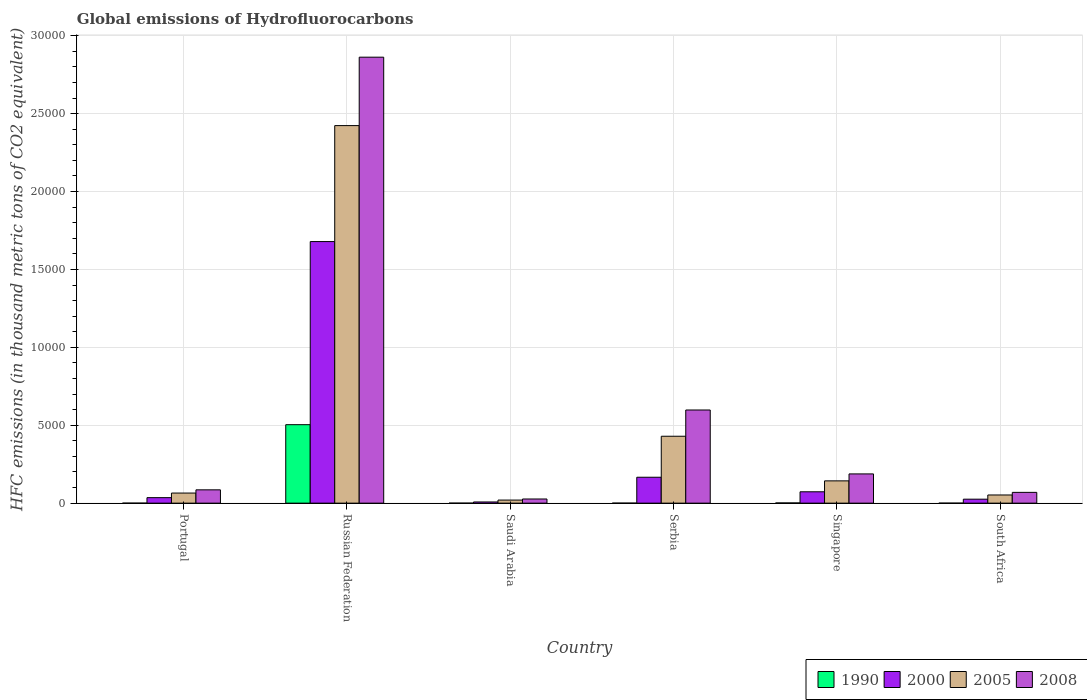How many different coloured bars are there?
Keep it short and to the point. 4. How many groups of bars are there?
Offer a very short reply. 6. Are the number of bars on each tick of the X-axis equal?
Make the answer very short. Yes. What is the label of the 5th group of bars from the left?
Provide a short and direct response. Singapore. What is the global emissions of Hydrofluorocarbons in 2005 in Saudi Arabia?
Provide a succinct answer. 196.9. Across all countries, what is the maximum global emissions of Hydrofluorocarbons in 2008?
Keep it short and to the point. 2.86e+04. In which country was the global emissions of Hydrofluorocarbons in 2000 maximum?
Your response must be concise. Russian Federation. In which country was the global emissions of Hydrofluorocarbons in 2000 minimum?
Make the answer very short. Saudi Arabia. What is the total global emissions of Hydrofluorocarbons in 2008 in the graph?
Keep it short and to the point. 3.83e+04. What is the difference between the global emissions of Hydrofluorocarbons in 1990 in Serbia and that in Singapore?
Offer a terse response. -12.1. What is the difference between the global emissions of Hydrofluorocarbons in 2005 in South Africa and the global emissions of Hydrofluorocarbons in 2000 in Russian Federation?
Your response must be concise. -1.63e+04. What is the average global emissions of Hydrofluorocarbons in 2005 per country?
Provide a succinct answer. 5220.65. What is the difference between the global emissions of Hydrofluorocarbons of/in 2005 and global emissions of Hydrofluorocarbons of/in 2000 in Serbia?
Provide a short and direct response. 2631.8. In how many countries, is the global emissions of Hydrofluorocarbons in 1990 greater than 4000 thousand metric tons?
Give a very brief answer. 1. What is the ratio of the global emissions of Hydrofluorocarbons in 2008 in Portugal to that in Saudi Arabia?
Offer a terse response. 3.21. What is the difference between the highest and the second highest global emissions of Hydrofluorocarbons in 1990?
Provide a succinct answer. -5035.1. What is the difference between the highest and the lowest global emissions of Hydrofluorocarbons in 2008?
Offer a terse response. 2.84e+04. In how many countries, is the global emissions of Hydrofluorocarbons in 1990 greater than the average global emissions of Hydrofluorocarbons in 1990 taken over all countries?
Your answer should be very brief. 1. Is the sum of the global emissions of Hydrofluorocarbons in 2008 in Serbia and Singapore greater than the maximum global emissions of Hydrofluorocarbons in 2000 across all countries?
Your answer should be compact. No. What does the 4th bar from the left in Russian Federation represents?
Offer a very short reply. 2008. What does the 4th bar from the right in Serbia represents?
Your response must be concise. 1990. Is it the case that in every country, the sum of the global emissions of Hydrofluorocarbons in 1990 and global emissions of Hydrofluorocarbons in 2008 is greater than the global emissions of Hydrofluorocarbons in 2005?
Your answer should be compact. Yes. How many countries are there in the graph?
Keep it short and to the point. 6. What is the difference between two consecutive major ticks on the Y-axis?
Your answer should be compact. 5000. Are the values on the major ticks of Y-axis written in scientific E-notation?
Your answer should be compact. No. Does the graph contain any zero values?
Your answer should be very brief. No. Where does the legend appear in the graph?
Provide a short and direct response. Bottom right. How many legend labels are there?
Offer a very short reply. 4. How are the legend labels stacked?
Keep it short and to the point. Horizontal. What is the title of the graph?
Your answer should be very brief. Global emissions of Hydrofluorocarbons. What is the label or title of the X-axis?
Provide a short and direct response. Country. What is the label or title of the Y-axis?
Your answer should be compact. HFC emissions (in thousand metric tons of CO2 equivalent). What is the HFC emissions (in thousand metric tons of CO2 equivalent) of 2000 in Portugal?
Provide a succinct answer. 352.7. What is the HFC emissions (in thousand metric tons of CO2 equivalent) of 2005 in Portugal?
Provide a short and direct response. 647.7. What is the HFC emissions (in thousand metric tons of CO2 equivalent) of 2008 in Portugal?
Your response must be concise. 854.4. What is the HFC emissions (in thousand metric tons of CO2 equivalent) of 1990 in Russian Federation?
Your response must be concise. 5035.6. What is the HFC emissions (in thousand metric tons of CO2 equivalent) in 2000 in Russian Federation?
Give a very brief answer. 1.68e+04. What is the HFC emissions (in thousand metric tons of CO2 equivalent) in 2005 in Russian Federation?
Your response must be concise. 2.42e+04. What is the HFC emissions (in thousand metric tons of CO2 equivalent) in 2008 in Russian Federation?
Your response must be concise. 2.86e+04. What is the HFC emissions (in thousand metric tons of CO2 equivalent) of 1990 in Saudi Arabia?
Offer a terse response. 0.1. What is the HFC emissions (in thousand metric tons of CO2 equivalent) of 2000 in Saudi Arabia?
Your answer should be very brief. 75.5. What is the HFC emissions (in thousand metric tons of CO2 equivalent) of 2005 in Saudi Arabia?
Your response must be concise. 196.9. What is the HFC emissions (in thousand metric tons of CO2 equivalent) in 2008 in Saudi Arabia?
Keep it short and to the point. 266.5. What is the HFC emissions (in thousand metric tons of CO2 equivalent) of 1990 in Serbia?
Offer a very short reply. 0.5. What is the HFC emissions (in thousand metric tons of CO2 equivalent) of 2000 in Serbia?
Keep it short and to the point. 1662. What is the HFC emissions (in thousand metric tons of CO2 equivalent) in 2005 in Serbia?
Ensure brevity in your answer.  4293.8. What is the HFC emissions (in thousand metric tons of CO2 equivalent) in 2008 in Serbia?
Offer a terse response. 5979. What is the HFC emissions (in thousand metric tons of CO2 equivalent) of 1990 in Singapore?
Keep it short and to the point. 12.6. What is the HFC emissions (in thousand metric tons of CO2 equivalent) in 2000 in Singapore?
Offer a very short reply. 728.9. What is the HFC emissions (in thousand metric tons of CO2 equivalent) in 2005 in Singapore?
Keep it short and to the point. 1429.7. What is the HFC emissions (in thousand metric tons of CO2 equivalent) of 2008 in Singapore?
Offer a very short reply. 1876.4. What is the HFC emissions (in thousand metric tons of CO2 equivalent) of 1990 in South Africa?
Give a very brief answer. 0.2. What is the HFC emissions (in thousand metric tons of CO2 equivalent) in 2000 in South Africa?
Your answer should be compact. 254.6. What is the HFC emissions (in thousand metric tons of CO2 equivalent) of 2005 in South Africa?
Ensure brevity in your answer.  524.5. What is the HFC emissions (in thousand metric tons of CO2 equivalent) in 2008 in South Africa?
Provide a short and direct response. 691.6. Across all countries, what is the maximum HFC emissions (in thousand metric tons of CO2 equivalent) of 1990?
Give a very brief answer. 5035.6. Across all countries, what is the maximum HFC emissions (in thousand metric tons of CO2 equivalent) of 2000?
Make the answer very short. 1.68e+04. Across all countries, what is the maximum HFC emissions (in thousand metric tons of CO2 equivalent) of 2005?
Your answer should be very brief. 2.42e+04. Across all countries, what is the maximum HFC emissions (in thousand metric tons of CO2 equivalent) of 2008?
Ensure brevity in your answer.  2.86e+04. Across all countries, what is the minimum HFC emissions (in thousand metric tons of CO2 equivalent) of 2000?
Offer a very short reply. 75.5. Across all countries, what is the minimum HFC emissions (in thousand metric tons of CO2 equivalent) in 2005?
Your answer should be compact. 196.9. Across all countries, what is the minimum HFC emissions (in thousand metric tons of CO2 equivalent) of 2008?
Your answer should be very brief. 266.5. What is the total HFC emissions (in thousand metric tons of CO2 equivalent) of 1990 in the graph?
Offer a terse response. 5049.2. What is the total HFC emissions (in thousand metric tons of CO2 equivalent) in 2000 in the graph?
Your answer should be very brief. 1.99e+04. What is the total HFC emissions (in thousand metric tons of CO2 equivalent) in 2005 in the graph?
Keep it short and to the point. 3.13e+04. What is the total HFC emissions (in thousand metric tons of CO2 equivalent) in 2008 in the graph?
Offer a very short reply. 3.83e+04. What is the difference between the HFC emissions (in thousand metric tons of CO2 equivalent) in 1990 in Portugal and that in Russian Federation?
Ensure brevity in your answer.  -5035.4. What is the difference between the HFC emissions (in thousand metric tons of CO2 equivalent) of 2000 in Portugal and that in Russian Federation?
Offer a very short reply. -1.64e+04. What is the difference between the HFC emissions (in thousand metric tons of CO2 equivalent) in 2005 in Portugal and that in Russian Federation?
Your response must be concise. -2.36e+04. What is the difference between the HFC emissions (in thousand metric tons of CO2 equivalent) in 2008 in Portugal and that in Russian Federation?
Ensure brevity in your answer.  -2.78e+04. What is the difference between the HFC emissions (in thousand metric tons of CO2 equivalent) in 1990 in Portugal and that in Saudi Arabia?
Keep it short and to the point. 0.1. What is the difference between the HFC emissions (in thousand metric tons of CO2 equivalent) in 2000 in Portugal and that in Saudi Arabia?
Provide a short and direct response. 277.2. What is the difference between the HFC emissions (in thousand metric tons of CO2 equivalent) of 2005 in Portugal and that in Saudi Arabia?
Provide a short and direct response. 450.8. What is the difference between the HFC emissions (in thousand metric tons of CO2 equivalent) in 2008 in Portugal and that in Saudi Arabia?
Your answer should be very brief. 587.9. What is the difference between the HFC emissions (in thousand metric tons of CO2 equivalent) of 2000 in Portugal and that in Serbia?
Provide a short and direct response. -1309.3. What is the difference between the HFC emissions (in thousand metric tons of CO2 equivalent) of 2005 in Portugal and that in Serbia?
Your answer should be compact. -3646.1. What is the difference between the HFC emissions (in thousand metric tons of CO2 equivalent) of 2008 in Portugal and that in Serbia?
Provide a succinct answer. -5124.6. What is the difference between the HFC emissions (in thousand metric tons of CO2 equivalent) in 1990 in Portugal and that in Singapore?
Make the answer very short. -12.4. What is the difference between the HFC emissions (in thousand metric tons of CO2 equivalent) of 2000 in Portugal and that in Singapore?
Make the answer very short. -376.2. What is the difference between the HFC emissions (in thousand metric tons of CO2 equivalent) in 2005 in Portugal and that in Singapore?
Your answer should be very brief. -782. What is the difference between the HFC emissions (in thousand metric tons of CO2 equivalent) in 2008 in Portugal and that in Singapore?
Keep it short and to the point. -1022. What is the difference between the HFC emissions (in thousand metric tons of CO2 equivalent) of 2000 in Portugal and that in South Africa?
Your answer should be very brief. 98.1. What is the difference between the HFC emissions (in thousand metric tons of CO2 equivalent) of 2005 in Portugal and that in South Africa?
Offer a terse response. 123.2. What is the difference between the HFC emissions (in thousand metric tons of CO2 equivalent) of 2008 in Portugal and that in South Africa?
Make the answer very short. 162.8. What is the difference between the HFC emissions (in thousand metric tons of CO2 equivalent) in 1990 in Russian Federation and that in Saudi Arabia?
Provide a short and direct response. 5035.5. What is the difference between the HFC emissions (in thousand metric tons of CO2 equivalent) of 2000 in Russian Federation and that in Saudi Arabia?
Your answer should be compact. 1.67e+04. What is the difference between the HFC emissions (in thousand metric tons of CO2 equivalent) of 2005 in Russian Federation and that in Saudi Arabia?
Provide a short and direct response. 2.40e+04. What is the difference between the HFC emissions (in thousand metric tons of CO2 equivalent) of 2008 in Russian Federation and that in Saudi Arabia?
Make the answer very short. 2.84e+04. What is the difference between the HFC emissions (in thousand metric tons of CO2 equivalent) of 1990 in Russian Federation and that in Serbia?
Keep it short and to the point. 5035.1. What is the difference between the HFC emissions (in thousand metric tons of CO2 equivalent) of 2000 in Russian Federation and that in Serbia?
Provide a succinct answer. 1.51e+04. What is the difference between the HFC emissions (in thousand metric tons of CO2 equivalent) of 2005 in Russian Federation and that in Serbia?
Your answer should be compact. 1.99e+04. What is the difference between the HFC emissions (in thousand metric tons of CO2 equivalent) of 2008 in Russian Federation and that in Serbia?
Give a very brief answer. 2.26e+04. What is the difference between the HFC emissions (in thousand metric tons of CO2 equivalent) in 1990 in Russian Federation and that in Singapore?
Your answer should be compact. 5023. What is the difference between the HFC emissions (in thousand metric tons of CO2 equivalent) in 2000 in Russian Federation and that in Singapore?
Keep it short and to the point. 1.61e+04. What is the difference between the HFC emissions (in thousand metric tons of CO2 equivalent) in 2005 in Russian Federation and that in Singapore?
Keep it short and to the point. 2.28e+04. What is the difference between the HFC emissions (in thousand metric tons of CO2 equivalent) in 2008 in Russian Federation and that in Singapore?
Keep it short and to the point. 2.67e+04. What is the difference between the HFC emissions (in thousand metric tons of CO2 equivalent) in 1990 in Russian Federation and that in South Africa?
Provide a succinct answer. 5035.4. What is the difference between the HFC emissions (in thousand metric tons of CO2 equivalent) in 2000 in Russian Federation and that in South Africa?
Give a very brief answer. 1.65e+04. What is the difference between the HFC emissions (in thousand metric tons of CO2 equivalent) in 2005 in Russian Federation and that in South Africa?
Provide a short and direct response. 2.37e+04. What is the difference between the HFC emissions (in thousand metric tons of CO2 equivalent) of 2008 in Russian Federation and that in South Africa?
Your response must be concise. 2.79e+04. What is the difference between the HFC emissions (in thousand metric tons of CO2 equivalent) in 1990 in Saudi Arabia and that in Serbia?
Provide a succinct answer. -0.4. What is the difference between the HFC emissions (in thousand metric tons of CO2 equivalent) in 2000 in Saudi Arabia and that in Serbia?
Ensure brevity in your answer.  -1586.5. What is the difference between the HFC emissions (in thousand metric tons of CO2 equivalent) in 2005 in Saudi Arabia and that in Serbia?
Your answer should be compact. -4096.9. What is the difference between the HFC emissions (in thousand metric tons of CO2 equivalent) in 2008 in Saudi Arabia and that in Serbia?
Make the answer very short. -5712.5. What is the difference between the HFC emissions (in thousand metric tons of CO2 equivalent) of 2000 in Saudi Arabia and that in Singapore?
Provide a short and direct response. -653.4. What is the difference between the HFC emissions (in thousand metric tons of CO2 equivalent) of 2005 in Saudi Arabia and that in Singapore?
Ensure brevity in your answer.  -1232.8. What is the difference between the HFC emissions (in thousand metric tons of CO2 equivalent) of 2008 in Saudi Arabia and that in Singapore?
Your response must be concise. -1609.9. What is the difference between the HFC emissions (in thousand metric tons of CO2 equivalent) in 2000 in Saudi Arabia and that in South Africa?
Keep it short and to the point. -179.1. What is the difference between the HFC emissions (in thousand metric tons of CO2 equivalent) in 2005 in Saudi Arabia and that in South Africa?
Your answer should be compact. -327.6. What is the difference between the HFC emissions (in thousand metric tons of CO2 equivalent) in 2008 in Saudi Arabia and that in South Africa?
Offer a very short reply. -425.1. What is the difference between the HFC emissions (in thousand metric tons of CO2 equivalent) in 2000 in Serbia and that in Singapore?
Make the answer very short. 933.1. What is the difference between the HFC emissions (in thousand metric tons of CO2 equivalent) of 2005 in Serbia and that in Singapore?
Your response must be concise. 2864.1. What is the difference between the HFC emissions (in thousand metric tons of CO2 equivalent) of 2008 in Serbia and that in Singapore?
Your answer should be very brief. 4102.6. What is the difference between the HFC emissions (in thousand metric tons of CO2 equivalent) of 1990 in Serbia and that in South Africa?
Provide a short and direct response. 0.3. What is the difference between the HFC emissions (in thousand metric tons of CO2 equivalent) of 2000 in Serbia and that in South Africa?
Provide a succinct answer. 1407.4. What is the difference between the HFC emissions (in thousand metric tons of CO2 equivalent) in 2005 in Serbia and that in South Africa?
Give a very brief answer. 3769.3. What is the difference between the HFC emissions (in thousand metric tons of CO2 equivalent) of 2008 in Serbia and that in South Africa?
Keep it short and to the point. 5287.4. What is the difference between the HFC emissions (in thousand metric tons of CO2 equivalent) in 2000 in Singapore and that in South Africa?
Offer a very short reply. 474.3. What is the difference between the HFC emissions (in thousand metric tons of CO2 equivalent) of 2005 in Singapore and that in South Africa?
Your response must be concise. 905.2. What is the difference between the HFC emissions (in thousand metric tons of CO2 equivalent) in 2008 in Singapore and that in South Africa?
Provide a short and direct response. 1184.8. What is the difference between the HFC emissions (in thousand metric tons of CO2 equivalent) of 1990 in Portugal and the HFC emissions (in thousand metric tons of CO2 equivalent) of 2000 in Russian Federation?
Keep it short and to the point. -1.68e+04. What is the difference between the HFC emissions (in thousand metric tons of CO2 equivalent) of 1990 in Portugal and the HFC emissions (in thousand metric tons of CO2 equivalent) of 2005 in Russian Federation?
Provide a succinct answer. -2.42e+04. What is the difference between the HFC emissions (in thousand metric tons of CO2 equivalent) in 1990 in Portugal and the HFC emissions (in thousand metric tons of CO2 equivalent) in 2008 in Russian Federation?
Keep it short and to the point. -2.86e+04. What is the difference between the HFC emissions (in thousand metric tons of CO2 equivalent) in 2000 in Portugal and the HFC emissions (in thousand metric tons of CO2 equivalent) in 2005 in Russian Federation?
Give a very brief answer. -2.39e+04. What is the difference between the HFC emissions (in thousand metric tons of CO2 equivalent) in 2000 in Portugal and the HFC emissions (in thousand metric tons of CO2 equivalent) in 2008 in Russian Federation?
Your response must be concise. -2.83e+04. What is the difference between the HFC emissions (in thousand metric tons of CO2 equivalent) in 2005 in Portugal and the HFC emissions (in thousand metric tons of CO2 equivalent) in 2008 in Russian Federation?
Your response must be concise. -2.80e+04. What is the difference between the HFC emissions (in thousand metric tons of CO2 equivalent) of 1990 in Portugal and the HFC emissions (in thousand metric tons of CO2 equivalent) of 2000 in Saudi Arabia?
Your answer should be compact. -75.3. What is the difference between the HFC emissions (in thousand metric tons of CO2 equivalent) of 1990 in Portugal and the HFC emissions (in thousand metric tons of CO2 equivalent) of 2005 in Saudi Arabia?
Keep it short and to the point. -196.7. What is the difference between the HFC emissions (in thousand metric tons of CO2 equivalent) in 1990 in Portugal and the HFC emissions (in thousand metric tons of CO2 equivalent) in 2008 in Saudi Arabia?
Offer a very short reply. -266.3. What is the difference between the HFC emissions (in thousand metric tons of CO2 equivalent) in 2000 in Portugal and the HFC emissions (in thousand metric tons of CO2 equivalent) in 2005 in Saudi Arabia?
Make the answer very short. 155.8. What is the difference between the HFC emissions (in thousand metric tons of CO2 equivalent) of 2000 in Portugal and the HFC emissions (in thousand metric tons of CO2 equivalent) of 2008 in Saudi Arabia?
Offer a terse response. 86.2. What is the difference between the HFC emissions (in thousand metric tons of CO2 equivalent) of 2005 in Portugal and the HFC emissions (in thousand metric tons of CO2 equivalent) of 2008 in Saudi Arabia?
Offer a terse response. 381.2. What is the difference between the HFC emissions (in thousand metric tons of CO2 equivalent) in 1990 in Portugal and the HFC emissions (in thousand metric tons of CO2 equivalent) in 2000 in Serbia?
Your response must be concise. -1661.8. What is the difference between the HFC emissions (in thousand metric tons of CO2 equivalent) in 1990 in Portugal and the HFC emissions (in thousand metric tons of CO2 equivalent) in 2005 in Serbia?
Provide a succinct answer. -4293.6. What is the difference between the HFC emissions (in thousand metric tons of CO2 equivalent) in 1990 in Portugal and the HFC emissions (in thousand metric tons of CO2 equivalent) in 2008 in Serbia?
Your answer should be very brief. -5978.8. What is the difference between the HFC emissions (in thousand metric tons of CO2 equivalent) in 2000 in Portugal and the HFC emissions (in thousand metric tons of CO2 equivalent) in 2005 in Serbia?
Keep it short and to the point. -3941.1. What is the difference between the HFC emissions (in thousand metric tons of CO2 equivalent) in 2000 in Portugal and the HFC emissions (in thousand metric tons of CO2 equivalent) in 2008 in Serbia?
Your response must be concise. -5626.3. What is the difference between the HFC emissions (in thousand metric tons of CO2 equivalent) of 2005 in Portugal and the HFC emissions (in thousand metric tons of CO2 equivalent) of 2008 in Serbia?
Provide a short and direct response. -5331.3. What is the difference between the HFC emissions (in thousand metric tons of CO2 equivalent) of 1990 in Portugal and the HFC emissions (in thousand metric tons of CO2 equivalent) of 2000 in Singapore?
Your answer should be compact. -728.7. What is the difference between the HFC emissions (in thousand metric tons of CO2 equivalent) of 1990 in Portugal and the HFC emissions (in thousand metric tons of CO2 equivalent) of 2005 in Singapore?
Your answer should be very brief. -1429.5. What is the difference between the HFC emissions (in thousand metric tons of CO2 equivalent) in 1990 in Portugal and the HFC emissions (in thousand metric tons of CO2 equivalent) in 2008 in Singapore?
Keep it short and to the point. -1876.2. What is the difference between the HFC emissions (in thousand metric tons of CO2 equivalent) of 2000 in Portugal and the HFC emissions (in thousand metric tons of CO2 equivalent) of 2005 in Singapore?
Give a very brief answer. -1077. What is the difference between the HFC emissions (in thousand metric tons of CO2 equivalent) of 2000 in Portugal and the HFC emissions (in thousand metric tons of CO2 equivalent) of 2008 in Singapore?
Provide a short and direct response. -1523.7. What is the difference between the HFC emissions (in thousand metric tons of CO2 equivalent) of 2005 in Portugal and the HFC emissions (in thousand metric tons of CO2 equivalent) of 2008 in Singapore?
Give a very brief answer. -1228.7. What is the difference between the HFC emissions (in thousand metric tons of CO2 equivalent) of 1990 in Portugal and the HFC emissions (in thousand metric tons of CO2 equivalent) of 2000 in South Africa?
Provide a short and direct response. -254.4. What is the difference between the HFC emissions (in thousand metric tons of CO2 equivalent) in 1990 in Portugal and the HFC emissions (in thousand metric tons of CO2 equivalent) in 2005 in South Africa?
Make the answer very short. -524.3. What is the difference between the HFC emissions (in thousand metric tons of CO2 equivalent) in 1990 in Portugal and the HFC emissions (in thousand metric tons of CO2 equivalent) in 2008 in South Africa?
Your answer should be very brief. -691.4. What is the difference between the HFC emissions (in thousand metric tons of CO2 equivalent) of 2000 in Portugal and the HFC emissions (in thousand metric tons of CO2 equivalent) of 2005 in South Africa?
Ensure brevity in your answer.  -171.8. What is the difference between the HFC emissions (in thousand metric tons of CO2 equivalent) in 2000 in Portugal and the HFC emissions (in thousand metric tons of CO2 equivalent) in 2008 in South Africa?
Your response must be concise. -338.9. What is the difference between the HFC emissions (in thousand metric tons of CO2 equivalent) of 2005 in Portugal and the HFC emissions (in thousand metric tons of CO2 equivalent) of 2008 in South Africa?
Offer a terse response. -43.9. What is the difference between the HFC emissions (in thousand metric tons of CO2 equivalent) of 1990 in Russian Federation and the HFC emissions (in thousand metric tons of CO2 equivalent) of 2000 in Saudi Arabia?
Provide a short and direct response. 4960.1. What is the difference between the HFC emissions (in thousand metric tons of CO2 equivalent) in 1990 in Russian Federation and the HFC emissions (in thousand metric tons of CO2 equivalent) in 2005 in Saudi Arabia?
Provide a succinct answer. 4838.7. What is the difference between the HFC emissions (in thousand metric tons of CO2 equivalent) of 1990 in Russian Federation and the HFC emissions (in thousand metric tons of CO2 equivalent) of 2008 in Saudi Arabia?
Offer a terse response. 4769.1. What is the difference between the HFC emissions (in thousand metric tons of CO2 equivalent) in 2000 in Russian Federation and the HFC emissions (in thousand metric tons of CO2 equivalent) in 2005 in Saudi Arabia?
Your response must be concise. 1.66e+04. What is the difference between the HFC emissions (in thousand metric tons of CO2 equivalent) of 2000 in Russian Federation and the HFC emissions (in thousand metric tons of CO2 equivalent) of 2008 in Saudi Arabia?
Keep it short and to the point. 1.65e+04. What is the difference between the HFC emissions (in thousand metric tons of CO2 equivalent) of 2005 in Russian Federation and the HFC emissions (in thousand metric tons of CO2 equivalent) of 2008 in Saudi Arabia?
Give a very brief answer. 2.40e+04. What is the difference between the HFC emissions (in thousand metric tons of CO2 equivalent) of 1990 in Russian Federation and the HFC emissions (in thousand metric tons of CO2 equivalent) of 2000 in Serbia?
Keep it short and to the point. 3373.6. What is the difference between the HFC emissions (in thousand metric tons of CO2 equivalent) of 1990 in Russian Federation and the HFC emissions (in thousand metric tons of CO2 equivalent) of 2005 in Serbia?
Your answer should be compact. 741.8. What is the difference between the HFC emissions (in thousand metric tons of CO2 equivalent) in 1990 in Russian Federation and the HFC emissions (in thousand metric tons of CO2 equivalent) in 2008 in Serbia?
Provide a short and direct response. -943.4. What is the difference between the HFC emissions (in thousand metric tons of CO2 equivalent) in 2000 in Russian Federation and the HFC emissions (in thousand metric tons of CO2 equivalent) in 2005 in Serbia?
Your answer should be very brief. 1.25e+04. What is the difference between the HFC emissions (in thousand metric tons of CO2 equivalent) in 2000 in Russian Federation and the HFC emissions (in thousand metric tons of CO2 equivalent) in 2008 in Serbia?
Keep it short and to the point. 1.08e+04. What is the difference between the HFC emissions (in thousand metric tons of CO2 equivalent) in 2005 in Russian Federation and the HFC emissions (in thousand metric tons of CO2 equivalent) in 2008 in Serbia?
Keep it short and to the point. 1.83e+04. What is the difference between the HFC emissions (in thousand metric tons of CO2 equivalent) in 1990 in Russian Federation and the HFC emissions (in thousand metric tons of CO2 equivalent) in 2000 in Singapore?
Ensure brevity in your answer.  4306.7. What is the difference between the HFC emissions (in thousand metric tons of CO2 equivalent) in 1990 in Russian Federation and the HFC emissions (in thousand metric tons of CO2 equivalent) in 2005 in Singapore?
Your answer should be very brief. 3605.9. What is the difference between the HFC emissions (in thousand metric tons of CO2 equivalent) in 1990 in Russian Federation and the HFC emissions (in thousand metric tons of CO2 equivalent) in 2008 in Singapore?
Provide a succinct answer. 3159.2. What is the difference between the HFC emissions (in thousand metric tons of CO2 equivalent) of 2000 in Russian Federation and the HFC emissions (in thousand metric tons of CO2 equivalent) of 2005 in Singapore?
Your response must be concise. 1.54e+04. What is the difference between the HFC emissions (in thousand metric tons of CO2 equivalent) in 2000 in Russian Federation and the HFC emissions (in thousand metric tons of CO2 equivalent) in 2008 in Singapore?
Provide a short and direct response. 1.49e+04. What is the difference between the HFC emissions (in thousand metric tons of CO2 equivalent) in 2005 in Russian Federation and the HFC emissions (in thousand metric tons of CO2 equivalent) in 2008 in Singapore?
Give a very brief answer. 2.24e+04. What is the difference between the HFC emissions (in thousand metric tons of CO2 equivalent) in 1990 in Russian Federation and the HFC emissions (in thousand metric tons of CO2 equivalent) in 2000 in South Africa?
Your response must be concise. 4781. What is the difference between the HFC emissions (in thousand metric tons of CO2 equivalent) of 1990 in Russian Federation and the HFC emissions (in thousand metric tons of CO2 equivalent) of 2005 in South Africa?
Provide a succinct answer. 4511.1. What is the difference between the HFC emissions (in thousand metric tons of CO2 equivalent) of 1990 in Russian Federation and the HFC emissions (in thousand metric tons of CO2 equivalent) of 2008 in South Africa?
Offer a very short reply. 4344. What is the difference between the HFC emissions (in thousand metric tons of CO2 equivalent) in 2000 in Russian Federation and the HFC emissions (in thousand metric tons of CO2 equivalent) in 2005 in South Africa?
Give a very brief answer. 1.63e+04. What is the difference between the HFC emissions (in thousand metric tons of CO2 equivalent) of 2000 in Russian Federation and the HFC emissions (in thousand metric tons of CO2 equivalent) of 2008 in South Africa?
Offer a terse response. 1.61e+04. What is the difference between the HFC emissions (in thousand metric tons of CO2 equivalent) of 2005 in Russian Federation and the HFC emissions (in thousand metric tons of CO2 equivalent) of 2008 in South Africa?
Keep it short and to the point. 2.35e+04. What is the difference between the HFC emissions (in thousand metric tons of CO2 equivalent) of 1990 in Saudi Arabia and the HFC emissions (in thousand metric tons of CO2 equivalent) of 2000 in Serbia?
Keep it short and to the point. -1661.9. What is the difference between the HFC emissions (in thousand metric tons of CO2 equivalent) in 1990 in Saudi Arabia and the HFC emissions (in thousand metric tons of CO2 equivalent) in 2005 in Serbia?
Provide a succinct answer. -4293.7. What is the difference between the HFC emissions (in thousand metric tons of CO2 equivalent) in 1990 in Saudi Arabia and the HFC emissions (in thousand metric tons of CO2 equivalent) in 2008 in Serbia?
Offer a terse response. -5978.9. What is the difference between the HFC emissions (in thousand metric tons of CO2 equivalent) in 2000 in Saudi Arabia and the HFC emissions (in thousand metric tons of CO2 equivalent) in 2005 in Serbia?
Your answer should be compact. -4218.3. What is the difference between the HFC emissions (in thousand metric tons of CO2 equivalent) in 2000 in Saudi Arabia and the HFC emissions (in thousand metric tons of CO2 equivalent) in 2008 in Serbia?
Ensure brevity in your answer.  -5903.5. What is the difference between the HFC emissions (in thousand metric tons of CO2 equivalent) of 2005 in Saudi Arabia and the HFC emissions (in thousand metric tons of CO2 equivalent) of 2008 in Serbia?
Provide a succinct answer. -5782.1. What is the difference between the HFC emissions (in thousand metric tons of CO2 equivalent) of 1990 in Saudi Arabia and the HFC emissions (in thousand metric tons of CO2 equivalent) of 2000 in Singapore?
Your response must be concise. -728.8. What is the difference between the HFC emissions (in thousand metric tons of CO2 equivalent) in 1990 in Saudi Arabia and the HFC emissions (in thousand metric tons of CO2 equivalent) in 2005 in Singapore?
Your answer should be very brief. -1429.6. What is the difference between the HFC emissions (in thousand metric tons of CO2 equivalent) of 1990 in Saudi Arabia and the HFC emissions (in thousand metric tons of CO2 equivalent) of 2008 in Singapore?
Provide a succinct answer. -1876.3. What is the difference between the HFC emissions (in thousand metric tons of CO2 equivalent) in 2000 in Saudi Arabia and the HFC emissions (in thousand metric tons of CO2 equivalent) in 2005 in Singapore?
Your answer should be very brief. -1354.2. What is the difference between the HFC emissions (in thousand metric tons of CO2 equivalent) of 2000 in Saudi Arabia and the HFC emissions (in thousand metric tons of CO2 equivalent) of 2008 in Singapore?
Your response must be concise. -1800.9. What is the difference between the HFC emissions (in thousand metric tons of CO2 equivalent) of 2005 in Saudi Arabia and the HFC emissions (in thousand metric tons of CO2 equivalent) of 2008 in Singapore?
Your response must be concise. -1679.5. What is the difference between the HFC emissions (in thousand metric tons of CO2 equivalent) in 1990 in Saudi Arabia and the HFC emissions (in thousand metric tons of CO2 equivalent) in 2000 in South Africa?
Provide a succinct answer. -254.5. What is the difference between the HFC emissions (in thousand metric tons of CO2 equivalent) of 1990 in Saudi Arabia and the HFC emissions (in thousand metric tons of CO2 equivalent) of 2005 in South Africa?
Offer a terse response. -524.4. What is the difference between the HFC emissions (in thousand metric tons of CO2 equivalent) of 1990 in Saudi Arabia and the HFC emissions (in thousand metric tons of CO2 equivalent) of 2008 in South Africa?
Your response must be concise. -691.5. What is the difference between the HFC emissions (in thousand metric tons of CO2 equivalent) of 2000 in Saudi Arabia and the HFC emissions (in thousand metric tons of CO2 equivalent) of 2005 in South Africa?
Ensure brevity in your answer.  -449. What is the difference between the HFC emissions (in thousand metric tons of CO2 equivalent) in 2000 in Saudi Arabia and the HFC emissions (in thousand metric tons of CO2 equivalent) in 2008 in South Africa?
Offer a very short reply. -616.1. What is the difference between the HFC emissions (in thousand metric tons of CO2 equivalent) of 2005 in Saudi Arabia and the HFC emissions (in thousand metric tons of CO2 equivalent) of 2008 in South Africa?
Keep it short and to the point. -494.7. What is the difference between the HFC emissions (in thousand metric tons of CO2 equivalent) of 1990 in Serbia and the HFC emissions (in thousand metric tons of CO2 equivalent) of 2000 in Singapore?
Your response must be concise. -728.4. What is the difference between the HFC emissions (in thousand metric tons of CO2 equivalent) of 1990 in Serbia and the HFC emissions (in thousand metric tons of CO2 equivalent) of 2005 in Singapore?
Provide a succinct answer. -1429.2. What is the difference between the HFC emissions (in thousand metric tons of CO2 equivalent) of 1990 in Serbia and the HFC emissions (in thousand metric tons of CO2 equivalent) of 2008 in Singapore?
Provide a short and direct response. -1875.9. What is the difference between the HFC emissions (in thousand metric tons of CO2 equivalent) in 2000 in Serbia and the HFC emissions (in thousand metric tons of CO2 equivalent) in 2005 in Singapore?
Make the answer very short. 232.3. What is the difference between the HFC emissions (in thousand metric tons of CO2 equivalent) in 2000 in Serbia and the HFC emissions (in thousand metric tons of CO2 equivalent) in 2008 in Singapore?
Your response must be concise. -214.4. What is the difference between the HFC emissions (in thousand metric tons of CO2 equivalent) of 2005 in Serbia and the HFC emissions (in thousand metric tons of CO2 equivalent) of 2008 in Singapore?
Provide a short and direct response. 2417.4. What is the difference between the HFC emissions (in thousand metric tons of CO2 equivalent) in 1990 in Serbia and the HFC emissions (in thousand metric tons of CO2 equivalent) in 2000 in South Africa?
Your response must be concise. -254.1. What is the difference between the HFC emissions (in thousand metric tons of CO2 equivalent) of 1990 in Serbia and the HFC emissions (in thousand metric tons of CO2 equivalent) of 2005 in South Africa?
Your response must be concise. -524. What is the difference between the HFC emissions (in thousand metric tons of CO2 equivalent) of 1990 in Serbia and the HFC emissions (in thousand metric tons of CO2 equivalent) of 2008 in South Africa?
Make the answer very short. -691.1. What is the difference between the HFC emissions (in thousand metric tons of CO2 equivalent) in 2000 in Serbia and the HFC emissions (in thousand metric tons of CO2 equivalent) in 2005 in South Africa?
Make the answer very short. 1137.5. What is the difference between the HFC emissions (in thousand metric tons of CO2 equivalent) in 2000 in Serbia and the HFC emissions (in thousand metric tons of CO2 equivalent) in 2008 in South Africa?
Make the answer very short. 970.4. What is the difference between the HFC emissions (in thousand metric tons of CO2 equivalent) in 2005 in Serbia and the HFC emissions (in thousand metric tons of CO2 equivalent) in 2008 in South Africa?
Give a very brief answer. 3602.2. What is the difference between the HFC emissions (in thousand metric tons of CO2 equivalent) in 1990 in Singapore and the HFC emissions (in thousand metric tons of CO2 equivalent) in 2000 in South Africa?
Ensure brevity in your answer.  -242. What is the difference between the HFC emissions (in thousand metric tons of CO2 equivalent) in 1990 in Singapore and the HFC emissions (in thousand metric tons of CO2 equivalent) in 2005 in South Africa?
Make the answer very short. -511.9. What is the difference between the HFC emissions (in thousand metric tons of CO2 equivalent) of 1990 in Singapore and the HFC emissions (in thousand metric tons of CO2 equivalent) of 2008 in South Africa?
Your answer should be compact. -679. What is the difference between the HFC emissions (in thousand metric tons of CO2 equivalent) of 2000 in Singapore and the HFC emissions (in thousand metric tons of CO2 equivalent) of 2005 in South Africa?
Your answer should be compact. 204.4. What is the difference between the HFC emissions (in thousand metric tons of CO2 equivalent) of 2000 in Singapore and the HFC emissions (in thousand metric tons of CO2 equivalent) of 2008 in South Africa?
Keep it short and to the point. 37.3. What is the difference between the HFC emissions (in thousand metric tons of CO2 equivalent) of 2005 in Singapore and the HFC emissions (in thousand metric tons of CO2 equivalent) of 2008 in South Africa?
Give a very brief answer. 738.1. What is the average HFC emissions (in thousand metric tons of CO2 equivalent) in 1990 per country?
Give a very brief answer. 841.53. What is the average HFC emissions (in thousand metric tons of CO2 equivalent) in 2000 per country?
Your answer should be compact. 3310.4. What is the average HFC emissions (in thousand metric tons of CO2 equivalent) in 2005 per country?
Your answer should be very brief. 5220.65. What is the average HFC emissions (in thousand metric tons of CO2 equivalent) of 2008 per country?
Offer a terse response. 6381.9. What is the difference between the HFC emissions (in thousand metric tons of CO2 equivalent) of 1990 and HFC emissions (in thousand metric tons of CO2 equivalent) of 2000 in Portugal?
Keep it short and to the point. -352.5. What is the difference between the HFC emissions (in thousand metric tons of CO2 equivalent) of 1990 and HFC emissions (in thousand metric tons of CO2 equivalent) of 2005 in Portugal?
Your answer should be compact. -647.5. What is the difference between the HFC emissions (in thousand metric tons of CO2 equivalent) of 1990 and HFC emissions (in thousand metric tons of CO2 equivalent) of 2008 in Portugal?
Provide a short and direct response. -854.2. What is the difference between the HFC emissions (in thousand metric tons of CO2 equivalent) of 2000 and HFC emissions (in thousand metric tons of CO2 equivalent) of 2005 in Portugal?
Your response must be concise. -295. What is the difference between the HFC emissions (in thousand metric tons of CO2 equivalent) of 2000 and HFC emissions (in thousand metric tons of CO2 equivalent) of 2008 in Portugal?
Make the answer very short. -501.7. What is the difference between the HFC emissions (in thousand metric tons of CO2 equivalent) in 2005 and HFC emissions (in thousand metric tons of CO2 equivalent) in 2008 in Portugal?
Offer a very short reply. -206.7. What is the difference between the HFC emissions (in thousand metric tons of CO2 equivalent) in 1990 and HFC emissions (in thousand metric tons of CO2 equivalent) in 2000 in Russian Federation?
Make the answer very short. -1.18e+04. What is the difference between the HFC emissions (in thousand metric tons of CO2 equivalent) of 1990 and HFC emissions (in thousand metric tons of CO2 equivalent) of 2005 in Russian Federation?
Your answer should be compact. -1.92e+04. What is the difference between the HFC emissions (in thousand metric tons of CO2 equivalent) of 1990 and HFC emissions (in thousand metric tons of CO2 equivalent) of 2008 in Russian Federation?
Your answer should be compact. -2.36e+04. What is the difference between the HFC emissions (in thousand metric tons of CO2 equivalent) in 2000 and HFC emissions (in thousand metric tons of CO2 equivalent) in 2005 in Russian Federation?
Your response must be concise. -7442.6. What is the difference between the HFC emissions (in thousand metric tons of CO2 equivalent) in 2000 and HFC emissions (in thousand metric tons of CO2 equivalent) in 2008 in Russian Federation?
Your response must be concise. -1.18e+04. What is the difference between the HFC emissions (in thousand metric tons of CO2 equivalent) in 2005 and HFC emissions (in thousand metric tons of CO2 equivalent) in 2008 in Russian Federation?
Keep it short and to the point. -4392.2. What is the difference between the HFC emissions (in thousand metric tons of CO2 equivalent) in 1990 and HFC emissions (in thousand metric tons of CO2 equivalent) in 2000 in Saudi Arabia?
Your response must be concise. -75.4. What is the difference between the HFC emissions (in thousand metric tons of CO2 equivalent) of 1990 and HFC emissions (in thousand metric tons of CO2 equivalent) of 2005 in Saudi Arabia?
Offer a terse response. -196.8. What is the difference between the HFC emissions (in thousand metric tons of CO2 equivalent) of 1990 and HFC emissions (in thousand metric tons of CO2 equivalent) of 2008 in Saudi Arabia?
Your answer should be compact. -266.4. What is the difference between the HFC emissions (in thousand metric tons of CO2 equivalent) of 2000 and HFC emissions (in thousand metric tons of CO2 equivalent) of 2005 in Saudi Arabia?
Your answer should be very brief. -121.4. What is the difference between the HFC emissions (in thousand metric tons of CO2 equivalent) in 2000 and HFC emissions (in thousand metric tons of CO2 equivalent) in 2008 in Saudi Arabia?
Give a very brief answer. -191. What is the difference between the HFC emissions (in thousand metric tons of CO2 equivalent) of 2005 and HFC emissions (in thousand metric tons of CO2 equivalent) of 2008 in Saudi Arabia?
Make the answer very short. -69.6. What is the difference between the HFC emissions (in thousand metric tons of CO2 equivalent) in 1990 and HFC emissions (in thousand metric tons of CO2 equivalent) in 2000 in Serbia?
Ensure brevity in your answer.  -1661.5. What is the difference between the HFC emissions (in thousand metric tons of CO2 equivalent) of 1990 and HFC emissions (in thousand metric tons of CO2 equivalent) of 2005 in Serbia?
Offer a very short reply. -4293.3. What is the difference between the HFC emissions (in thousand metric tons of CO2 equivalent) of 1990 and HFC emissions (in thousand metric tons of CO2 equivalent) of 2008 in Serbia?
Provide a short and direct response. -5978.5. What is the difference between the HFC emissions (in thousand metric tons of CO2 equivalent) of 2000 and HFC emissions (in thousand metric tons of CO2 equivalent) of 2005 in Serbia?
Offer a very short reply. -2631.8. What is the difference between the HFC emissions (in thousand metric tons of CO2 equivalent) of 2000 and HFC emissions (in thousand metric tons of CO2 equivalent) of 2008 in Serbia?
Keep it short and to the point. -4317. What is the difference between the HFC emissions (in thousand metric tons of CO2 equivalent) of 2005 and HFC emissions (in thousand metric tons of CO2 equivalent) of 2008 in Serbia?
Provide a short and direct response. -1685.2. What is the difference between the HFC emissions (in thousand metric tons of CO2 equivalent) of 1990 and HFC emissions (in thousand metric tons of CO2 equivalent) of 2000 in Singapore?
Your answer should be very brief. -716.3. What is the difference between the HFC emissions (in thousand metric tons of CO2 equivalent) of 1990 and HFC emissions (in thousand metric tons of CO2 equivalent) of 2005 in Singapore?
Offer a terse response. -1417.1. What is the difference between the HFC emissions (in thousand metric tons of CO2 equivalent) of 1990 and HFC emissions (in thousand metric tons of CO2 equivalent) of 2008 in Singapore?
Your answer should be very brief. -1863.8. What is the difference between the HFC emissions (in thousand metric tons of CO2 equivalent) in 2000 and HFC emissions (in thousand metric tons of CO2 equivalent) in 2005 in Singapore?
Your response must be concise. -700.8. What is the difference between the HFC emissions (in thousand metric tons of CO2 equivalent) in 2000 and HFC emissions (in thousand metric tons of CO2 equivalent) in 2008 in Singapore?
Provide a short and direct response. -1147.5. What is the difference between the HFC emissions (in thousand metric tons of CO2 equivalent) in 2005 and HFC emissions (in thousand metric tons of CO2 equivalent) in 2008 in Singapore?
Your answer should be compact. -446.7. What is the difference between the HFC emissions (in thousand metric tons of CO2 equivalent) in 1990 and HFC emissions (in thousand metric tons of CO2 equivalent) in 2000 in South Africa?
Make the answer very short. -254.4. What is the difference between the HFC emissions (in thousand metric tons of CO2 equivalent) of 1990 and HFC emissions (in thousand metric tons of CO2 equivalent) of 2005 in South Africa?
Your answer should be compact. -524.3. What is the difference between the HFC emissions (in thousand metric tons of CO2 equivalent) of 1990 and HFC emissions (in thousand metric tons of CO2 equivalent) of 2008 in South Africa?
Offer a very short reply. -691.4. What is the difference between the HFC emissions (in thousand metric tons of CO2 equivalent) of 2000 and HFC emissions (in thousand metric tons of CO2 equivalent) of 2005 in South Africa?
Provide a succinct answer. -269.9. What is the difference between the HFC emissions (in thousand metric tons of CO2 equivalent) in 2000 and HFC emissions (in thousand metric tons of CO2 equivalent) in 2008 in South Africa?
Make the answer very short. -437. What is the difference between the HFC emissions (in thousand metric tons of CO2 equivalent) of 2005 and HFC emissions (in thousand metric tons of CO2 equivalent) of 2008 in South Africa?
Give a very brief answer. -167.1. What is the ratio of the HFC emissions (in thousand metric tons of CO2 equivalent) in 1990 in Portugal to that in Russian Federation?
Keep it short and to the point. 0. What is the ratio of the HFC emissions (in thousand metric tons of CO2 equivalent) of 2000 in Portugal to that in Russian Federation?
Make the answer very short. 0.02. What is the ratio of the HFC emissions (in thousand metric tons of CO2 equivalent) of 2005 in Portugal to that in Russian Federation?
Make the answer very short. 0.03. What is the ratio of the HFC emissions (in thousand metric tons of CO2 equivalent) in 2008 in Portugal to that in Russian Federation?
Your answer should be very brief. 0.03. What is the ratio of the HFC emissions (in thousand metric tons of CO2 equivalent) in 1990 in Portugal to that in Saudi Arabia?
Offer a very short reply. 2. What is the ratio of the HFC emissions (in thousand metric tons of CO2 equivalent) in 2000 in Portugal to that in Saudi Arabia?
Provide a succinct answer. 4.67. What is the ratio of the HFC emissions (in thousand metric tons of CO2 equivalent) of 2005 in Portugal to that in Saudi Arabia?
Your answer should be very brief. 3.29. What is the ratio of the HFC emissions (in thousand metric tons of CO2 equivalent) in 2008 in Portugal to that in Saudi Arabia?
Your answer should be compact. 3.21. What is the ratio of the HFC emissions (in thousand metric tons of CO2 equivalent) in 1990 in Portugal to that in Serbia?
Provide a short and direct response. 0.4. What is the ratio of the HFC emissions (in thousand metric tons of CO2 equivalent) in 2000 in Portugal to that in Serbia?
Offer a very short reply. 0.21. What is the ratio of the HFC emissions (in thousand metric tons of CO2 equivalent) of 2005 in Portugal to that in Serbia?
Provide a short and direct response. 0.15. What is the ratio of the HFC emissions (in thousand metric tons of CO2 equivalent) in 2008 in Portugal to that in Serbia?
Your answer should be very brief. 0.14. What is the ratio of the HFC emissions (in thousand metric tons of CO2 equivalent) in 1990 in Portugal to that in Singapore?
Keep it short and to the point. 0.02. What is the ratio of the HFC emissions (in thousand metric tons of CO2 equivalent) in 2000 in Portugal to that in Singapore?
Keep it short and to the point. 0.48. What is the ratio of the HFC emissions (in thousand metric tons of CO2 equivalent) in 2005 in Portugal to that in Singapore?
Offer a terse response. 0.45. What is the ratio of the HFC emissions (in thousand metric tons of CO2 equivalent) in 2008 in Portugal to that in Singapore?
Give a very brief answer. 0.46. What is the ratio of the HFC emissions (in thousand metric tons of CO2 equivalent) in 1990 in Portugal to that in South Africa?
Keep it short and to the point. 1. What is the ratio of the HFC emissions (in thousand metric tons of CO2 equivalent) of 2000 in Portugal to that in South Africa?
Keep it short and to the point. 1.39. What is the ratio of the HFC emissions (in thousand metric tons of CO2 equivalent) of 2005 in Portugal to that in South Africa?
Offer a very short reply. 1.23. What is the ratio of the HFC emissions (in thousand metric tons of CO2 equivalent) in 2008 in Portugal to that in South Africa?
Provide a succinct answer. 1.24. What is the ratio of the HFC emissions (in thousand metric tons of CO2 equivalent) of 1990 in Russian Federation to that in Saudi Arabia?
Provide a short and direct response. 5.04e+04. What is the ratio of the HFC emissions (in thousand metric tons of CO2 equivalent) in 2000 in Russian Federation to that in Saudi Arabia?
Make the answer very short. 222.37. What is the ratio of the HFC emissions (in thousand metric tons of CO2 equivalent) in 2005 in Russian Federation to that in Saudi Arabia?
Your answer should be compact. 123.06. What is the ratio of the HFC emissions (in thousand metric tons of CO2 equivalent) in 2008 in Russian Federation to that in Saudi Arabia?
Your answer should be very brief. 107.41. What is the ratio of the HFC emissions (in thousand metric tons of CO2 equivalent) in 1990 in Russian Federation to that in Serbia?
Offer a very short reply. 1.01e+04. What is the ratio of the HFC emissions (in thousand metric tons of CO2 equivalent) of 2000 in Russian Federation to that in Serbia?
Your response must be concise. 10.1. What is the ratio of the HFC emissions (in thousand metric tons of CO2 equivalent) of 2005 in Russian Federation to that in Serbia?
Provide a short and direct response. 5.64. What is the ratio of the HFC emissions (in thousand metric tons of CO2 equivalent) of 2008 in Russian Federation to that in Serbia?
Provide a succinct answer. 4.79. What is the ratio of the HFC emissions (in thousand metric tons of CO2 equivalent) in 1990 in Russian Federation to that in Singapore?
Your answer should be very brief. 399.65. What is the ratio of the HFC emissions (in thousand metric tons of CO2 equivalent) of 2000 in Russian Federation to that in Singapore?
Your answer should be compact. 23.03. What is the ratio of the HFC emissions (in thousand metric tons of CO2 equivalent) in 2005 in Russian Federation to that in Singapore?
Offer a terse response. 16.95. What is the ratio of the HFC emissions (in thousand metric tons of CO2 equivalent) of 2008 in Russian Federation to that in Singapore?
Keep it short and to the point. 15.25. What is the ratio of the HFC emissions (in thousand metric tons of CO2 equivalent) in 1990 in Russian Federation to that in South Africa?
Give a very brief answer. 2.52e+04. What is the ratio of the HFC emissions (in thousand metric tons of CO2 equivalent) of 2000 in Russian Federation to that in South Africa?
Provide a succinct answer. 65.94. What is the ratio of the HFC emissions (in thousand metric tons of CO2 equivalent) in 2005 in Russian Federation to that in South Africa?
Offer a very short reply. 46.2. What is the ratio of the HFC emissions (in thousand metric tons of CO2 equivalent) of 2008 in Russian Federation to that in South Africa?
Offer a terse response. 41.39. What is the ratio of the HFC emissions (in thousand metric tons of CO2 equivalent) in 1990 in Saudi Arabia to that in Serbia?
Keep it short and to the point. 0.2. What is the ratio of the HFC emissions (in thousand metric tons of CO2 equivalent) of 2000 in Saudi Arabia to that in Serbia?
Keep it short and to the point. 0.05. What is the ratio of the HFC emissions (in thousand metric tons of CO2 equivalent) of 2005 in Saudi Arabia to that in Serbia?
Offer a very short reply. 0.05. What is the ratio of the HFC emissions (in thousand metric tons of CO2 equivalent) of 2008 in Saudi Arabia to that in Serbia?
Ensure brevity in your answer.  0.04. What is the ratio of the HFC emissions (in thousand metric tons of CO2 equivalent) in 1990 in Saudi Arabia to that in Singapore?
Your answer should be very brief. 0.01. What is the ratio of the HFC emissions (in thousand metric tons of CO2 equivalent) of 2000 in Saudi Arabia to that in Singapore?
Your answer should be compact. 0.1. What is the ratio of the HFC emissions (in thousand metric tons of CO2 equivalent) in 2005 in Saudi Arabia to that in Singapore?
Offer a very short reply. 0.14. What is the ratio of the HFC emissions (in thousand metric tons of CO2 equivalent) in 2008 in Saudi Arabia to that in Singapore?
Your answer should be compact. 0.14. What is the ratio of the HFC emissions (in thousand metric tons of CO2 equivalent) of 2000 in Saudi Arabia to that in South Africa?
Provide a short and direct response. 0.3. What is the ratio of the HFC emissions (in thousand metric tons of CO2 equivalent) of 2005 in Saudi Arabia to that in South Africa?
Offer a terse response. 0.38. What is the ratio of the HFC emissions (in thousand metric tons of CO2 equivalent) in 2008 in Saudi Arabia to that in South Africa?
Offer a very short reply. 0.39. What is the ratio of the HFC emissions (in thousand metric tons of CO2 equivalent) of 1990 in Serbia to that in Singapore?
Offer a very short reply. 0.04. What is the ratio of the HFC emissions (in thousand metric tons of CO2 equivalent) in 2000 in Serbia to that in Singapore?
Ensure brevity in your answer.  2.28. What is the ratio of the HFC emissions (in thousand metric tons of CO2 equivalent) of 2005 in Serbia to that in Singapore?
Offer a terse response. 3. What is the ratio of the HFC emissions (in thousand metric tons of CO2 equivalent) in 2008 in Serbia to that in Singapore?
Keep it short and to the point. 3.19. What is the ratio of the HFC emissions (in thousand metric tons of CO2 equivalent) of 1990 in Serbia to that in South Africa?
Offer a terse response. 2.5. What is the ratio of the HFC emissions (in thousand metric tons of CO2 equivalent) in 2000 in Serbia to that in South Africa?
Give a very brief answer. 6.53. What is the ratio of the HFC emissions (in thousand metric tons of CO2 equivalent) of 2005 in Serbia to that in South Africa?
Your answer should be very brief. 8.19. What is the ratio of the HFC emissions (in thousand metric tons of CO2 equivalent) of 2008 in Serbia to that in South Africa?
Ensure brevity in your answer.  8.65. What is the ratio of the HFC emissions (in thousand metric tons of CO2 equivalent) of 1990 in Singapore to that in South Africa?
Your response must be concise. 63. What is the ratio of the HFC emissions (in thousand metric tons of CO2 equivalent) in 2000 in Singapore to that in South Africa?
Ensure brevity in your answer.  2.86. What is the ratio of the HFC emissions (in thousand metric tons of CO2 equivalent) of 2005 in Singapore to that in South Africa?
Offer a very short reply. 2.73. What is the ratio of the HFC emissions (in thousand metric tons of CO2 equivalent) in 2008 in Singapore to that in South Africa?
Offer a terse response. 2.71. What is the difference between the highest and the second highest HFC emissions (in thousand metric tons of CO2 equivalent) in 1990?
Your answer should be compact. 5023. What is the difference between the highest and the second highest HFC emissions (in thousand metric tons of CO2 equivalent) of 2000?
Ensure brevity in your answer.  1.51e+04. What is the difference between the highest and the second highest HFC emissions (in thousand metric tons of CO2 equivalent) of 2005?
Your response must be concise. 1.99e+04. What is the difference between the highest and the second highest HFC emissions (in thousand metric tons of CO2 equivalent) of 2008?
Give a very brief answer. 2.26e+04. What is the difference between the highest and the lowest HFC emissions (in thousand metric tons of CO2 equivalent) in 1990?
Provide a short and direct response. 5035.5. What is the difference between the highest and the lowest HFC emissions (in thousand metric tons of CO2 equivalent) in 2000?
Your answer should be compact. 1.67e+04. What is the difference between the highest and the lowest HFC emissions (in thousand metric tons of CO2 equivalent) in 2005?
Give a very brief answer. 2.40e+04. What is the difference between the highest and the lowest HFC emissions (in thousand metric tons of CO2 equivalent) in 2008?
Provide a succinct answer. 2.84e+04. 